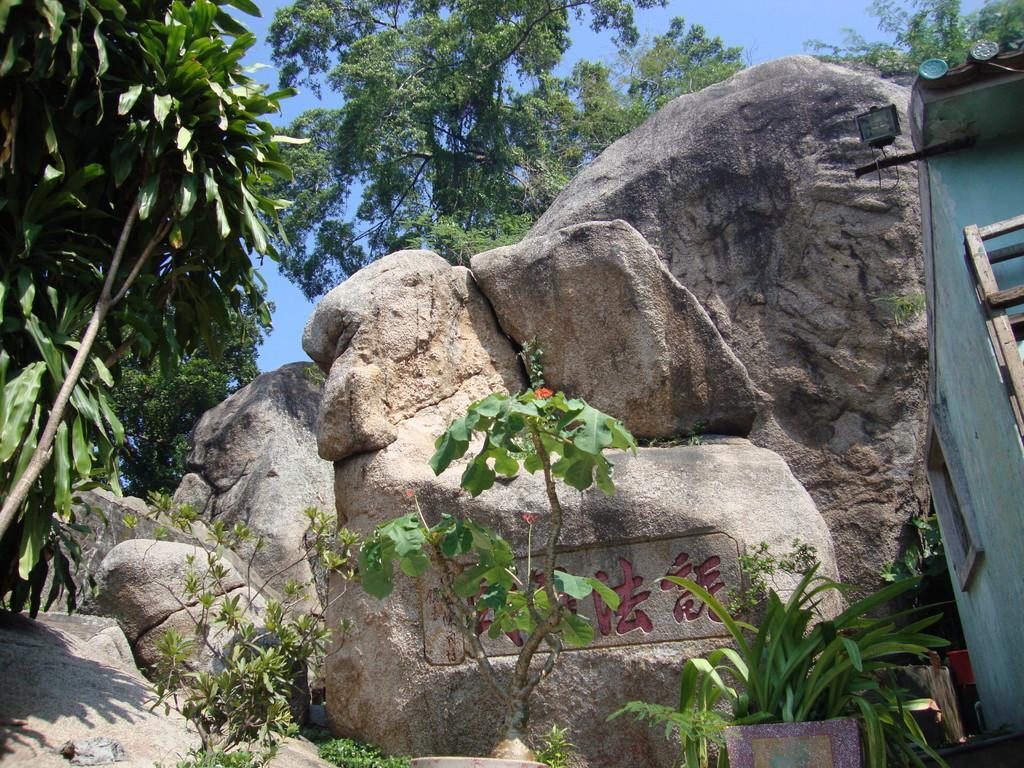In one or two sentences, can you explain what this image depicts? In this image we can see potted plants, rock and trees. We can see house on the right side of the image. The sky is in blue color. 